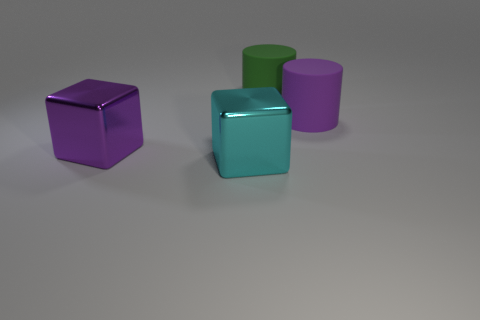Add 1 cylinders. How many objects exist? 5 Add 2 tiny cyan balls. How many tiny cyan balls exist? 2 Subtract all purple blocks. How many blocks are left? 1 Subtract 1 purple cylinders. How many objects are left? 3 Subtract 1 cubes. How many cubes are left? 1 Subtract all yellow cylinders. Subtract all purple spheres. How many cylinders are left? 2 Subtract all cyan cubes. How many red cylinders are left? 0 Subtract all large purple things. Subtract all large rubber objects. How many objects are left? 0 Add 2 large purple rubber cylinders. How many large purple rubber cylinders are left? 3 